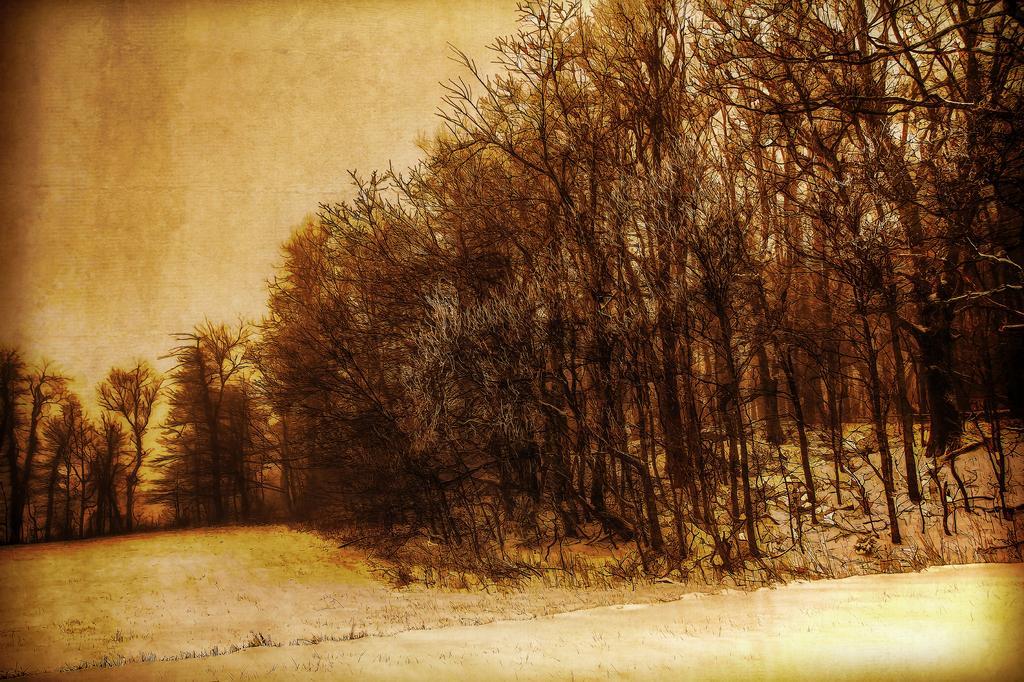In one or two sentences, can you explain what this image depicts? In the picture I can see trees, the ground and the sky. This image is a painting. 